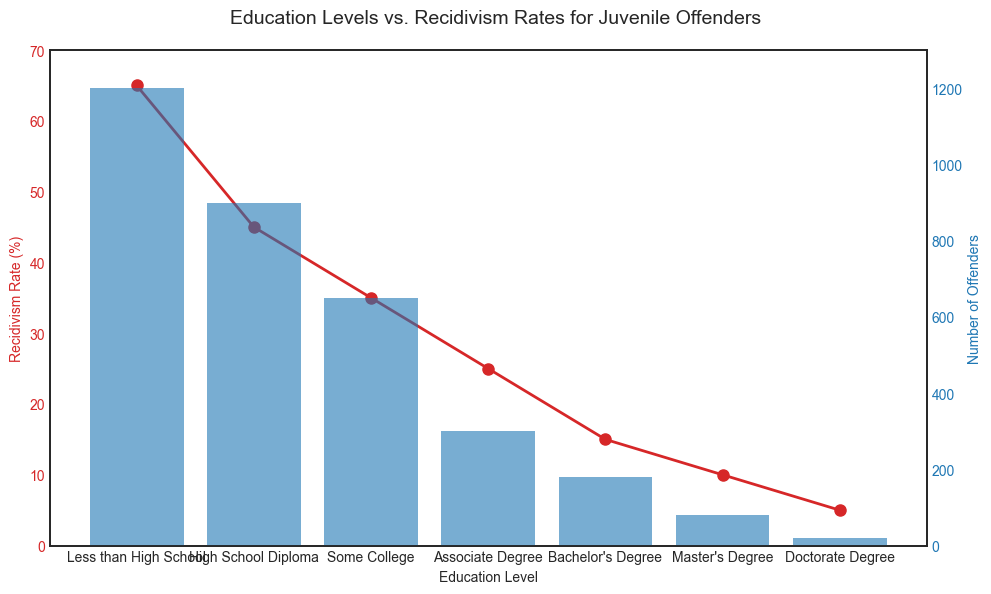Which education level has the highest recidivism rate? The red line shows recidivism rates by education level. The highest point on the line corresponds to "Less than High School" at 65%.
Answer: Less than High School What is the difference in recidivism rates between those with a Bachelor's Degree and those with a Master's Degree? The recidivism rates for Bachelor's Degree is 15% and for Master's Degree is 10%. The difference is 15% - 10% = 5%.
Answer: 5% How does the number of offenders with a High School Diploma compare to those with an Associate Degree? The blue bars represent the number of offenders. The height of the bar for High School Diploma is about 900 and for Associate Degree is about 300. So, the number for High School Diploma is higher.
Answer: High School Diploma is higher What is the combined recidivism rate for those with Any College Education (Some College, Associate Degree, Bachelor's Degree, and above)? Sum the recidivism rates for each relevant education level: Some College (35%) + Associate Degree (25%) + Bachelor's Degree (15%) + Master's Degree (10%) + Doctorate Degree (5%) = 90%.
Answer: 90% Which education level has the smallest number of offenders? The smallest blue bar corresponds to the Doctorate Degree, indicating the smallest number of offenders.
Answer: Doctorate Degree Is there a correlation between education level and recidivism rate? Observing the red line, there is a downward trend in recidivism rates as education levels increase, suggesting a negative correlation.
Answer: Yes, a negative correlation What are the recidivism rates for education levels Higher than High School Diploma? Recidivism rates for Some College (35%), Associate Degree (25%), Bachelor's Degree (15%), Master's Degree (10%), Doctorate Degree (5%).
Answer: 35%, 25%, 15%, 10%, 5% How does the recidivism rate change from "Less than High School" to a "High School Diploma"? The recidivism rate decreases from 65% for "Less than High School" to 45% for "High School Diploma".
Answer: Decreases Which color represents the number of offenders in the chart? The blue bars represent the number of offenders for each education level.
Answer: Blue Estimate the approximate number of offenders with a "Doctorate Degree". The height of the blue bar for "Doctorate Degree" is very small, close to the 20 mark.
Answer: Approximately 20 